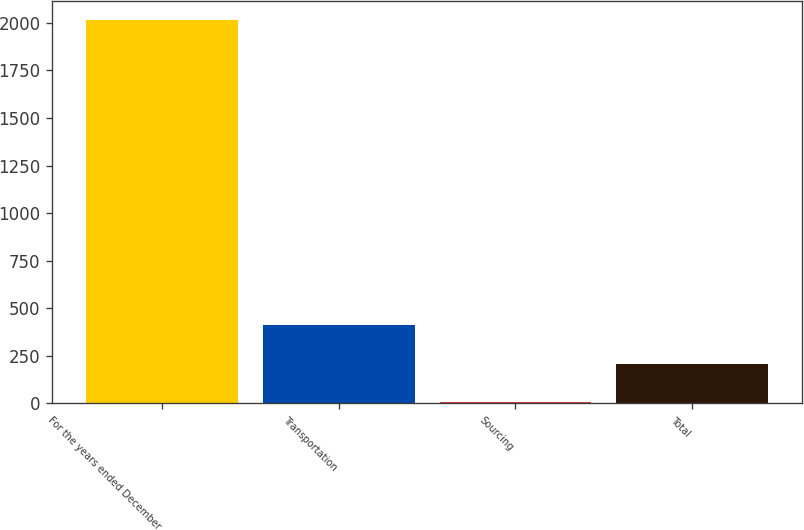<chart> <loc_0><loc_0><loc_500><loc_500><bar_chart><fcel>For the years ended December<fcel>Transportation<fcel>Sourcing<fcel>Total<nl><fcel>2016<fcel>410<fcel>8.5<fcel>209.25<nl></chart> 